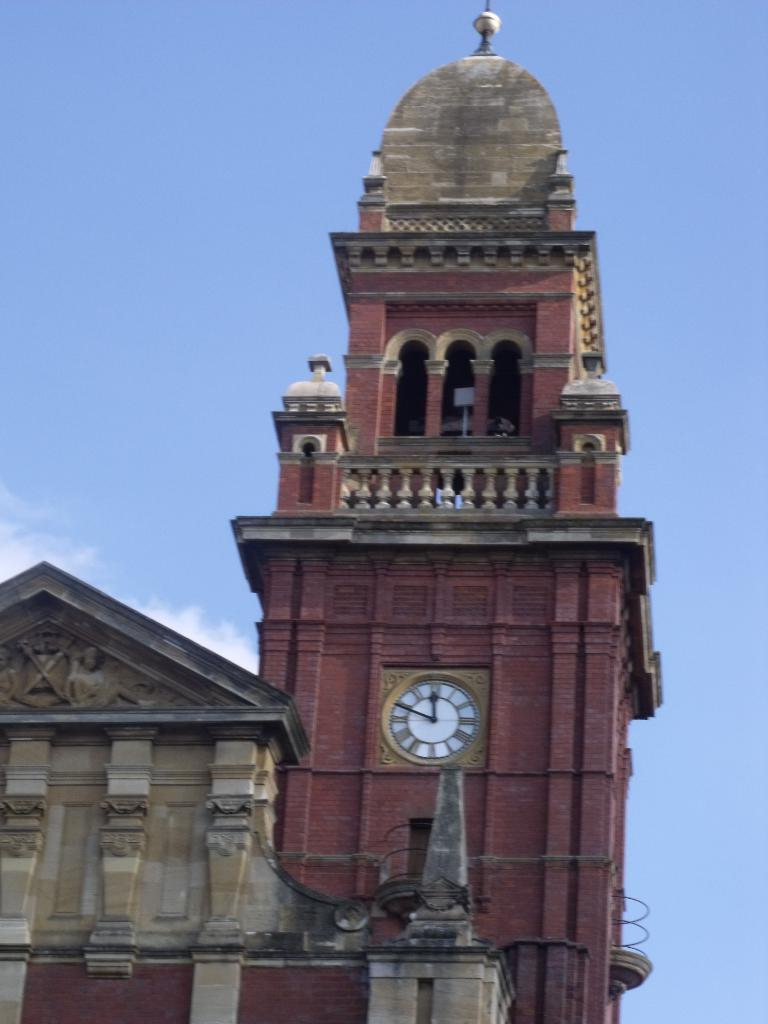What is the main subject of the image? There is a big structure in the image. What feature can be seen on the structure? The structure has a clock in it. What is visible at the top of the image? The sky is visible at the top of the image. What is the account number of the person standing next to the structure in the image? There is no person standing next to the structure in the image, so there is no account number to provide. 